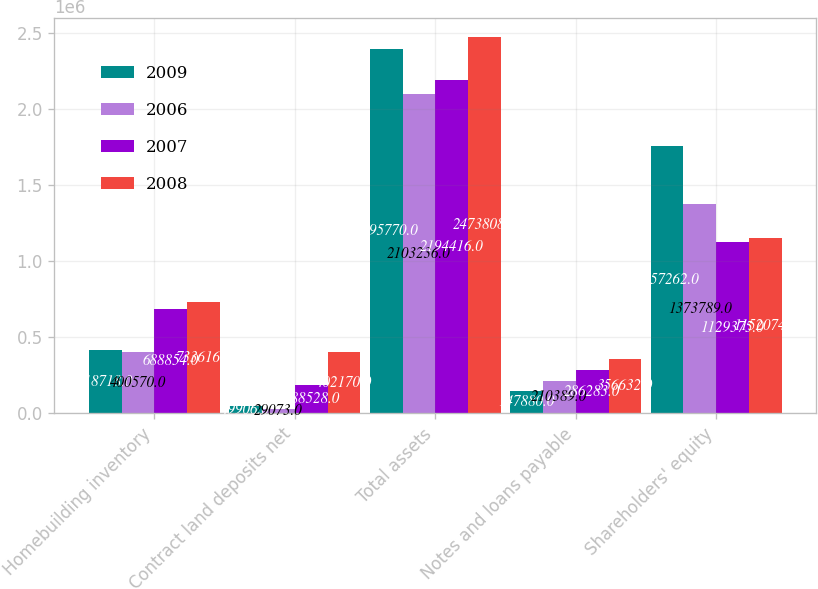Convert chart to OTSL. <chart><loc_0><loc_0><loc_500><loc_500><stacked_bar_chart><ecel><fcel>Homebuilding inventory<fcel>Contract land deposits net<fcel>Total assets<fcel>Notes and loans payable<fcel>Shareholders' equity<nl><fcel>2009<fcel>418718<fcel>49906<fcel>2.39577e+06<fcel>147880<fcel>1.75726e+06<nl><fcel>2006<fcel>400570<fcel>29073<fcel>2.10324e+06<fcel>210389<fcel>1.37379e+06<nl><fcel>2007<fcel>688854<fcel>188528<fcel>2.19442e+06<fcel>286283<fcel>1.12938e+06<nl><fcel>2008<fcel>733616<fcel>402170<fcel>2.47381e+06<fcel>356632<fcel>1.15207e+06<nl></chart> 